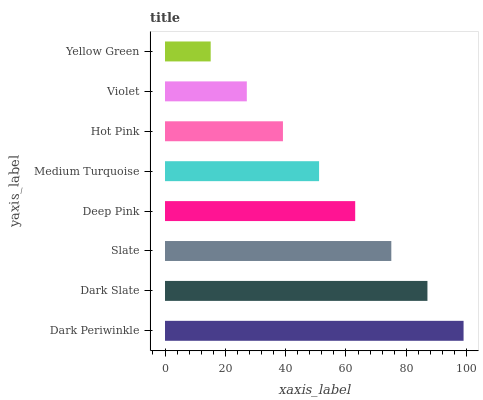Is Yellow Green the minimum?
Answer yes or no. Yes. Is Dark Periwinkle the maximum?
Answer yes or no. Yes. Is Dark Slate the minimum?
Answer yes or no. No. Is Dark Slate the maximum?
Answer yes or no. No. Is Dark Periwinkle greater than Dark Slate?
Answer yes or no. Yes. Is Dark Slate less than Dark Periwinkle?
Answer yes or no. Yes. Is Dark Slate greater than Dark Periwinkle?
Answer yes or no. No. Is Dark Periwinkle less than Dark Slate?
Answer yes or no. No. Is Deep Pink the high median?
Answer yes or no. Yes. Is Medium Turquoise the low median?
Answer yes or no. Yes. Is Slate the high median?
Answer yes or no. No. Is Dark Periwinkle the low median?
Answer yes or no. No. 